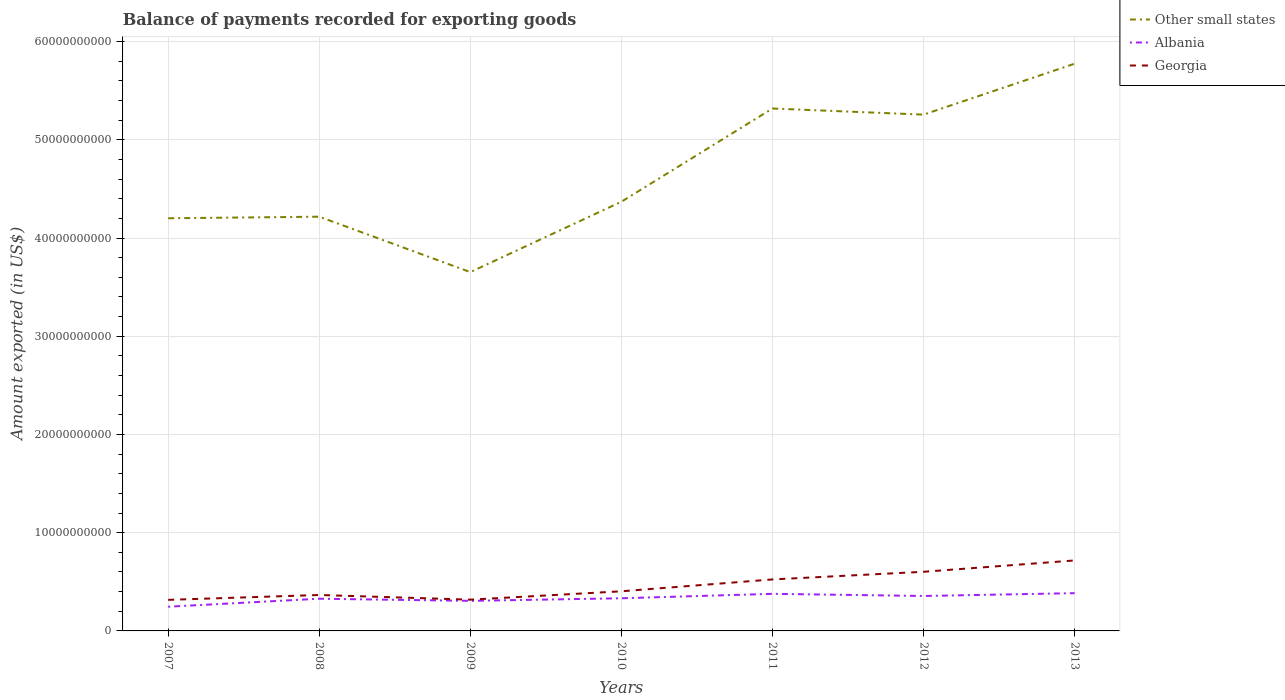Does the line corresponding to Georgia intersect with the line corresponding to Albania?
Your answer should be compact. No. Is the number of lines equal to the number of legend labels?
Make the answer very short. Yes. Across all years, what is the maximum amount exported in Georgia?
Ensure brevity in your answer.  3.16e+09. In which year was the amount exported in Georgia maximum?
Keep it short and to the point. 2007. What is the total amount exported in Georgia in the graph?
Give a very brief answer. -2.86e+09. What is the difference between the highest and the second highest amount exported in Albania?
Give a very brief answer. 1.38e+09. What is the difference between the highest and the lowest amount exported in Georgia?
Your response must be concise. 3. How many lines are there?
Offer a terse response. 3. How many years are there in the graph?
Ensure brevity in your answer.  7. Are the values on the major ticks of Y-axis written in scientific E-notation?
Your response must be concise. No. Does the graph contain grids?
Your response must be concise. Yes. Where does the legend appear in the graph?
Your answer should be very brief. Top right. What is the title of the graph?
Provide a succinct answer. Balance of payments recorded for exporting goods. Does "Armenia" appear as one of the legend labels in the graph?
Give a very brief answer. No. What is the label or title of the X-axis?
Provide a short and direct response. Years. What is the label or title of the Y-axis?
Your answer should be compact. Amount exported (in US$). What is the Amount exported (in US$) of Other small states in 2007?
Provide a succinct answer. 4.20e+1. What is the Amount exported (in US$) in Albania in 2007?
Ensure brevity in your answer.  2.46e+09. What is the Amount exported (in US$) in Georgia in 2007?
Your answer should be very brief. 3.16e+09. What is the Amount exported (in US$) in Other small states in 2008?
Provide a succinct answer. 4.22e+1. What is the Amount exported (in US$) in Albania in 2008?
Offer a very short reply. 3.28e+09. What is the Amount exported (in US$) in Georgia in 2008?
Your response must be concise. 3.66e+09. What is the Amount exported (in US$) of Other small states in 2009?
Offer a very short reply. 3.65e+1. What is the Amount exported (in US$) in Albania in 2009?
Give a very brief answer. 3.06e+09. What is the Amount exported (in US$) in Georgia in 2009?
Offer a very short reply. 3.18e+09. What is the Amount exported (in US$) in Other small states in 2010?
Provide a succinct answer. 4.37e+1. What is the Amount exported (in US$) in Albania in 2010?
Give a very brief answer. 3.32e+09. What is the Amount exported (in US$) in Georgia in 2010?
Ensure brevity in your answer.  4.03e+09. What is the Amount exported (in US$) of Other small states in 2011?
Your answer should be very brief. 5.32e+1. What is the Amount exported (in US$) of Albania in 2011?
Your answer should be compact. 3.78e+09. What is the Amount exported (in US$) of Georgia in 2011?
Your answer should be compact. 5.24e+09. What is the Amount exported (in US$) of Other small states in 2012?
Provide a succinct answer. 5.26e+1. What is the Amount exported (in US$) of Albania in 2012?
Offer a terse response. 3.56e+09. What is the Amount exported (in US$) of Georgia in 2012?
Your response must be concise. 6.02e+09. What is the Amount exported (in US$) in Other small states in 2013?
Make the answer very short. 5.77e+1. What is the Amount exported (in US$) of Albania in 2013?
Your answer should be compact. 3.84e+09. What is the Amount exported (in US$) of Georgia in 2013?
Make the answer very short. 7.17e+09. Across all years, what is the maximum Amount exported (in US$) in Other small states?
Ensure brevity in your answer.  5.77e+1. Across all years, what is the maximum Amount exported (in US$) in Albania?
Offer a terse response. 3.84e+09. Across all years, what is the maximum Amount exported (in US$) of Georgia?
Keep it short and to the point. 7.17e+09. Across all years, what is the minimum Amount exported (in US$) of Other small states?
Ensure brevity in your answer.  3.65e+1. Across all years, what is the minimum Amount exported (in US$) in Albania?
Provide a short and direct response. 2.46e+09. Across all years, what is the minimum Amount exported (in US$) in Georgia?
Keep it short and to the point. 3.16e+09. What is the total Amount exported (in US$) in Other small states in the graph?
Provide a succinct answer. 3.28e+11. What is the total Amount exported (in US$) in Albania in the graph?
Provide a succinct answer. 2.33e+1. What is the total Amount exported (in US$) in Georgia in the graph?
Ensure brevity in your answer.  3.25e+1. What is the difference between the Amount exported (in US$) of Other small states in 2007 and that in 2008?
Offer a terse response. -1.59e+08. What is the difference between the Amount exported (in US$) in Albania in 2007 and that in 2008?
Ensure brevity in your answer.  -8.14e+08. What is the difference between the Amount exported (in US$) of Georgia in 2007 and that in 2008?
Ensure brevity in your answer.  -4.96e+08. What is the difference between the Amount exported (in US$) in Other small states in 2007 and that in 2009?
Your response must be concise. 5.48e+09. What is the difference between the Amount exported (in US$) in Albania in 2007 and that in 2009?
Give a very brief answer. -5.97e+08. What is the difference between the Amount exported (in US$) in Georgia in 2007 and that in 2009?
Provide a succinct answer. -2.04e+07. What is the difference between the Amount exported (in US$) in Other small states in 2007 and that in 2010?
Keep it short and to the point. -1.68e+09. What is the difference between the Amount exported (in US$) of Albania in 2007 and that in 2010?
Offer a very short reply. -8.60e+08. What is the difference between the Amount exported (in US$) in Georgia in 2007 and that in 2010?
Your answer should be compact. -8.71e+08. What is the difference between the Amount exported (in US$) of Other small states in 2007 and that in 2011?
Your answer should be compact. -1.12e+1. What is the difference between the Amount exported (in US$) of Albania in 2007 and that in 2011?
Provide a short and direct response. -1.31e+09. What is the difference between the Amount exported (in US$) of Georgia in 2007 and that in 2011?
Give a very brief answer. -2.08e+09. What is the difference between the Amount exported (in US$) of Other small states in 2007 and that in 2012?
Provide a succinct answer. -1.06e+1. What is the difference between the Amount exported (in US$) of Albania in 2007 and that in 2012?
Your answer should be very brief. -1.09e+09. What is the difference between the Amount exported (in US$) of Georgia in 2007 and that in 2012?
Give a very brief answer. -2.86e+09. What is the difference between the Amount exported (in US$) in Other small states in 2007 and that in 2013?
Provide a short and direct response. -1.57e+1. What is the difference between the Amount exported (in US$) in Albania in 2007 and that in 2013?
Your answer should be compact. -1.38e+09. What is the difference between the Amount exported (in US$) in Georgia in 2007 and that in 2013?
Offer a very short reply. -4.01e+09. What is the difference between the Amount exported (in US$) in Other small states in 2008 and that in 2009?
Keep it short and to the point. 5.64e+09. What is the difference between the Amount exported (in US$) in Albania in 2008 and that in 2009?
Give a very brief answer. 2.17e+08. What is the difference between the Amount exported (in US$) in Georgia in 2008 and that in 2009?
Give a very brief answer. 4.75e+08. What is the difference between the Amount exported (in US$) in Other small states in 2008 and that in 2010?
Offer a terse response. -1.52e+09. What is the difference between the Amount exported (in US$) in Albania in 2008 and that in 2010?
Keep it short and to the point. -4.58e+07. What is the difference between the Amount exported (in US$) of Georgia in 2008 and that in 2010?
Your response must be concise. -3.76e+08. What is the difference between the Amount exported (in US$) in Other small states in 2008 and that in 2011?
Offer a very short reply. -1.10e+1. What is the difference between the Amount exported (in US$) in Albania in 2008 and that in 2011?
Give a very brief answer. -4.98e+08. What is the difference between the Amount exported (in US$) in Georgia in 2008 and that in 2011?
Your answer should be compact. -1.58e+09. What is the difference between the Amount exported (in US$) of Other small states in 2008 and that in 2012?
Your answer should be very brief. -1.04e+1. What is the difference between the Amount exported (in US$) of Albania in 2008 and that in 2012?
Make the answer very short. -2.79e+08. What is the difference between the Amount exported (in US$) of Georgia in 2008 and that in 2012?
Your response must be concise. -2.36e+09. What is the difference between the Amount exported (in US$) of Other small states in 2008 and that in 2013?
Your answer should be compact. -1.56e+1. What is the difference between the Amount exported (in US$) in Albania in 2008 and that in 2013?
Your answer should be very brief. -5.66e+08. What is the difference between the Amount exported (in US$) in Georgia in 2008 and that in 2013?
Your response must be concise. -3.52e+09. What is the difference between the Amount exported (in US$) of Other small states in 2009 and that in 2010?
Provide a succinct answer. -7.16e+09. What is the difference between the Amount exported (in US$) in Albania in 2009 and that in 2010?
Give a very brief answer. -2.63e+08. What is the difference between the Amount exported (in US$) in Georgia in 2009 and that in 2010?
Your response must be concise. -8.51e+08. What is the difference between the Amount exported (in US$) in Other small states in 2009 and that in 2011?
Your answer should be compact. -1.67e+1. What is the difference between the Amount exported (in US$) in Albania in 2009 and that in 2011?
Offer a terse response. -7.15e+08. What is the difference between the Amount exported (in US$) in Georgia in 2009 and that in 2011?
Ensure brevity in your answer.  -2.06e+09. What is the difference between the Amount exported (in US$) of Other small states in 2009 and that in 2012?
Your response must be concise. -1.60e+1. What is the difference between the Amount exported (in US$) of Albania in 2009 and that in 2012?
Provide a short and direct response. -4.96e+08. What is the difference between the Amount exported (in US$) of Georgia in 2009 and that in 2012?
Provide a short and direct response. -2.84e+09. What is the difference between the Amount exported (in US$) of Other small states in 2009 and that in 2013?
Give a very brief answer. -2.12e+1. What is the difference between the Amount exported (in US$) of Albania in 2009 and that in 2013?
Your answer should be very brief. -7.83e+08. What is the difference between the Amount exported (in US$) in Georgia in 2009 and that in 2013?
Make the answer very short. -3.99e+09. What is the difference between the Amount exported (in US$) in Other small states in 2010 and that in 2011?
Give a very brief answer. -9.49e+09. What is the difference between the Amount exported (in US$) in Albania in 2010 and that in 2011?
Your answer should be very brief. -4.52e+08. What is the difference between the Amount exported (in US$) of Georgia in 2010 and that in 2011?
Offer a very short reply. -1.21e+09. What is the difference between the Amount exported (in US$) of Other small states in 2010 and that in 2012?
Your answer should be very brief. -8.87e+09. What is the difference between the Amount exported (in US$) in Albania in 2010 and that in 2012?
Offer a very short reply. -2.33e+08. What is the difference between the Amount exported (in US$) of Georgia in 2010 and that in 2012?
Make the answer very short. -1.99e+09. What is the difference between the Amount exported (in US$) in Other small states in 2010 and that in 2013?
Offer a very short reply. -1.41e+1. What is the difference between the Amount exported (in US$) in Albania in 2010 and that in 2013?
Provide a short and direct response. -5.20e+08. What is the difference between the Amount exported (in US$) of Georgia in 2010 and that in 2013?
Keep it short and to the point. -3.14e+09. What is the difference between the Amount exported (in US$) of Other small states in 2011 and that in 2012?
Your response must be concise. 6.23e+08. What is the difference between the Amount exported (in US$) in Albania in 2011 and that in 2012?
Provide a short and direct response. 2.19e+08. What is the difference between the Amount exported (in US$) in Georgia in 2011 and that in 2012?
Offer a terse response. -7.79e+08. What is the difference between the Amount exported (in US$) of Other small states in 2011 and that in 2013?
Your answer should be very brief. -4.56e+09. What is the difference between the Amount exported (in US$) in Albania in 2011 and that in 2013?
Ensure brevity in your answer.  -6.77e+07. What is the difference between the Amount exported (in US$) in Georgia in 2011 and that in 2013?
Provide a short and direct response. -1.93e+09. What is the difference between the Amount exported (in US$) in Other small states in 2012 and that in 2013?
Give a very brief answer. -5.18e+09. What is the difference between the Amount exported (in US$) in Albania in 2012 and that in 2013?
Your answer should be very brief. -2.87e+08. What is the difference between the Amount exported (in US$) of Georgia in 2012 and that in 2013?
Offer a terse response. -1.15e+09. What is the difference between the Amount exported (in US$) of Other small states in 2007 and the Amount exported (in US$) of Albania in 2008?
Offer a very short reply. 3.87e+1. What is the difference between the Amount exported (in US$) of Other small states in 2007 and the Amount exported (in US$) of Georgia in 2008?
Give a very brief answer. 3.84e+1. What is the difference between the Amount exported (in US$) of Albania in 2007 and the Amount exported (in US$) of Georgia in 2008?
Your response must be concise. -1.19e+09. What is the difference between the Amount exported (in US$) in Other small states in 2007 and the Amount exported (in US$) in Albania in 2009?
Ensure brevity in your answer.  3.90e+1. What is the difference between the Amount exported (in US$) in Other small states in 2007 and the Amount exported (in US$) in Georgia in 2009?
Provide a short and direct response. 3.88e+1. What is the difference between the Amount exported (in US$) of Albania in 2007 and the Amount exported (in US$) of Georgia in 2009?
Provide a short and direct response. -7.19e+08. What is the difference between the Amount exported (in US$) in Other small states in 2007 and the Amount exported (in US$) in Albania in 2010?
Give a very brief answer. 3.87e+1. What is the difference between the Amount exported (in US$) of Other small states in 2007 and the Amount exported (in US$) of Georgia in 2010?
Keep it short and to the point. 3.80e+1. What is the difference between the Amount exported (in US$) of Albania in 2007 and the Amount exported (in US$) of Georgia in 2010?
Give a very brief answer. -1.57e+09. What is the difference between the Amount exported (in US$) in Other small states in 2007 and the Amount exported (in US$) in Albania in 2011?
Your answer should be compact. 3.82e+1. What is the difference between the Amount exported (in US$) in Other small states in 2007 and the Amount exported (in US$) in Georgia in 2011?
Give a very brief answer. 3.68e+1. What is the difference between the Amount exported (in US$) of Albania in 2007 and the Amount exported (in US$) of Georgia in 2011?
Your answer should be very brief. -2.78e+09. What is the difference between the Amount exported (in US$) of Other small states in 2007 and the Amount exported (in US$) of Albania in 2012?
Your answer should be compact. 3.85e+1. What is the difference between the Amount exported (in US$) in Other small states in 2007 and the Amount exported (in US$) in Georgia in 2012?
Ensure brevity in your answer.  3.60e+1. What is the difference between the Amount exported (in US$) in Albania in 2007 and the Amount exported (in US$) in Georgia in 2012?
Your answer should be very brief. -3.56e+09. What is the difference between the Amount exported (in US$) of Other small states in 2007 and the Amount exported (in US$) of Albania in 2013?
Make the answer very short. 3.82e+1. What is the difference between the Amount exported (in US$) in Other small states in 2007 and the Amount exported (in US$) in Georgia in 2013?
Offer a terse response. 3.48e+1. What is the difference between the Amount exported (in US$) of Albania in 2007 and the Amount exported (in US$) of Georgia in 2013?
Your answer should be compact. -4.71e+09. What is the difference between the Amount exported (in US$) of Other small states in 2008 and the Amount exported (in US$) of Albania in 2009?
Provide a succinct answer. 3.91e+1. What is the difference between the Amount exported (in US$) of Other small states in 2008 and the Amount exported (in US$) of Georgia in 2009?
Offer a very short reply. 3.90e+1. What is the difference between the Amount exported (in US$) in Albania in 2008 and the Amount exported (in US$) in Georgia in 2009?
Offer a very short reply. 9.52e+07. What is the difference between the Amount exported (in US$) in Other small states in 2008 and the Amount exported (in US$) in Albania in 2010?
Make the answer very short. 3.88e+1. What is the difference between the Amount exported (in US$) in Other small states in 2008 and the Amount exported (in US$) in Georgia in 2010?
Keep it short and to the point. 3.81e+1. What is the difference between the Amount exported (in US$) in Albania in 2008 and the Amount exported (in US$) in Georgia in 2010?
Your response must be concise. -7.56e+08. What is the difference between the Amount exported (in US$) of Other small states in 2008 and the Amount exported (in US$) of Albania in 2011?
Make the answer very short. 3.84e+1. What is the difference between the Amount exported (in US$) in Other small states in 2008 and the Amount exported (in US$) in Georgia in 2011?
Make the answer very short. 3.69e+1. What is the difference between the Amount exported (in US$) of Albania in 2008 and the Amount exported (in US$) of Georgia in 2011?
Make the answer very short. -1.96e+09. What is the difference between the Amount exported (in US$) in Other small states in 2008 and the Amount exported (in US$) in Albania in 2012?
Your answer should be compact. 3.86e+1. What is the difference between the Amount exported (in US$) of Other small states in 2008 and the Amount exported (in US$) of Georgia in 2012?
Keep it short and to the point. 3.61e+1. What is the difference between the Amount exported (in US$) of Albania in 2008 and the Amount exported (in US$) of Georgia in 2012?
Offer a very short reply. -2.74e+09. What is the difference between the Amount exported (in US$) in Other small states in 2008 and the Amount exported (in US$) in Albania in 2013?
Offer a very short reply. 3.83e+1. What is the difference between the Amount exported (in US$) in Other small states in 2008 and the Amount exported (in US$) in Georgia in 2013?
Keep it short and to the point. 3.50e+1. What is the difference between the Amount exported (in US$) of Albania in 2008 and the Amount exported (in US$) of Georgia in 2013?
Give a very brief answer. -3.90e+09. What is the difference between the Amount exported (in US$) in Other small states in 2009 and the Amount exported (in US$) in Albania in 2010?
Your answer should be very brief. 3.32e+1. What is the difference between the Amount exported (in US$) in Other small states in 2009 and the Amount exported (in US$) in Georgia in 2010?
Make the answer very short. 3.25e+1. What is the difference between the Amount exported (in US$) of Albania in 2009 and the Amount exported (in US$) of Georgia in 2010?
Keep it short and to the point. -9.73e+08. What is the difference between the Amount exported (in US$) in Other small states in 2009 and the Amount exported (in US$) in Albania in 2011?
Give a very brief answer. 3.28e+1. What is the difference between the Amount exported (in US$) of Other small states in 2009 and the Amount exported (in US$) of Georgia in 2011?
Offer a very short reply. 3.13e+1. What is the difference between the Amount exported (in US$) in Albania in 2009 and the Amount exported (in US$) in Georgia in 2011?
Your answer should be compact. -2.18e+09. What is the difference between the Amount exported (in US$) of Other small states in 2009 and the Amount exported (in US$) of Albania in 2012?
Give a very brief answer. 3.30e+1. What is the difference between the Amount exported (in US$) of Other small states in 2009 and the Amount exported (in US$) of Georgia in 2012?
Your answer should be compact. 3.05e+1. What is the difference between the Amount exported (in US$) in Albania in 2009 and the Amount exported (in US$) in Georgia in 2012?
Provide a succinct answer. -2.96e+09. What is the difference between the Amount exported (in US$) in Other small states in 2009 and the Amount exported (in US$) in Albania in 2013?
Offer a very short reply. 3.27e+1. What is the difference between the Amount exported (in US$) of Other small states in 2009 and the Amount exported (in US$) of Georgia in 2013?
Your answer should be very brief. 2.94e+1. What is the difference between the Amount exported (in US$) of Albania in 2009 and the Amount exported (in US$) of Georgia in 2013?
Provide a short and direct response. -4.11e+09. What is the difference between the Amount exported (in US$) in Other small states in 2010 and the Amount exported (in US$) in Albania in 2011?
Your answer should be compact. 3.99e+1. What is the difference between the Amount exported (in US$) in Other small states in 2010 and the Amount exported (in US$) in Georgia in 2011?
Offer a very short reply. 3.85e+1. What is the difference between the Amount exported (in US$) in Albania in 2010 and the Amount exported (in US$) in Georgia in 2011?
Offer a very short reply. -1.92e+09. What is the difference between the Amount exported (in US$) in Other small states in 2010 and the Amount exported (in US$) in Albania in 2012?
Make the answer very short. 4.01e+1. What is the difference between the Amount exported (in US$) of Other small states in 2010 and the Amount exported (in US$) of Georgia in 2012?
Ensure brevity in your answer.  3.77e+1. What is the difference between the Amount exported (in US$) in Albania in 2010 and the Amount exported (in US$) in Georgia in 2012?
Your answer should be compact. -2.70e+09. What is the difference between the Amount exported (in US$) of Other small states in 2010 and the Amount exported (in US$) of Albania in 2013?
Your response must be concise. 3.98e+1. What is the difference between the Amount exported (in US$) of Other small states in 2010 and the Amount exported (in US$) of Georgia in 2013?
Your answer should be compact. 3.65e+1. What is the difference between the Amount exported (in US$) in Albania in 2010 and the Amount exported (in US$) in Georgia in 2013?
Make the answer very short. -3.85e+09. What is the difference between the Amount exported (in US$) in Other small states in 2011 and the Amount exported (in US$) in Albania in 2012?
Make the answer very short. 4.96e+1. What is the difference between the Amount exported (in US$) of Other small states in 2011 and the Amount exported (in US$) of Georgia in 2012?
Provide a succinct answer. 4.72e+1. What is the difference between the Amount exported (in US$) of Albania in 2011 and the Amount exported (in US$) of Georgia in 2012?
Make the answer very short. -2.24e+09. What is the difference between the Amount exported (in US$) of Other small states in 2011 and the Amount exported (in US$) of Albania in 2013?
Make the answer very short. 4.93e+1. What is the difference between the Amount exported (in US$) in Other small states in 2011 and the Amount exported (in US$) in Georgia in 2013?
Give a very brief answer. 4.60e+1. What is the difference between the Amount exported (in US$) in Albania in 2011 and the Amount exported (in US$) in Georgia in 2013?
Your answer should be very brief. -3.40e+09. What is the difference between the Amount exported (in US$) in Other small states in 2012 and the Amount exported (in US$) in Albania in 2013?
Make the answer very short. 4.87e+1. What is the difference between the Amount exported (in US$) of Other small states in 2012 and the Amount exported (in US$) of Georgia in 2013?
Give a very brief answer. 4.54e+1. What is the difference between the Amount exported (in US$) of Albania in 2012 and the Amount exported (in US$) of Georgia in 2013?
Give a very brief answer. -3.62e+09. What is the average Amount exported (in US$) in Other small states per year?
Ensure brevity in your answer.  4.68e+1. What is the average Amount exported (in US$) in Albania per year?
Your answer should be very brief. 3.33e+09. What is the average Amount exported (in US$) in Georgia per year?
Make the answer very short. 4.64e+09. In the year 2007, what is the difference between the Amount exported (in US$) in Other small states and Amount exported (in US$) in Albania?
Provide a succinct answer. 3.95e+1. In the year 2007, what is the difference between the Amount exported (in US$) in Other small states and Amount exported (in US$) in Georgia?
Keep it short and to the point. 3.88e+1. In the year 2007, what is the difference between the Amount exported (in US$) of Albania and Amount exported (in US$) of Georgia?
Your answer should be compact. -6.98e+08. In the year 2008, what is the difference between the Amount exported (in US$) of Other small states and Amount exported (in US$) of Albania?
Your answer should be compact. 3.89e+1. In the year 2008, what is the difference between the Amount exported (in US$) of Other small states and Amount exported (in US$) of Georgia?
Make the answer very short. 3.85e+1. In the year 2008, what is the difference between the Amount exported (in US$) in Albania and Amount exported (in US$) in Georgia?
Offer a terse response. -3.80e+08. In the year 2009, what is the difference between the Amount exported (in US$) of Other small states and Amount exported (in US$) of Albania?
Keep it short and to the point. 3.35e+1. In the year 2009, what is the difference between the Amount exported (in US$) of Other small states and Amount exported (in US$) of Georgia?
Your answer should be very brief. 3.33e+1. In the year 2009, what is the difference between the Amount exported (in US$) of Albania and Amount exported (in US$) of Georgia?
Offer a very short reply. -1.22e+08. In the year 2010, what is the difference between the Amount exported (in US$) in Other small states and Amount exported (in US$) in Albania?
Offer a very short reply. 4.04e+1. In the year 2010, what is the difference between the Amount exported (in US$) in Other small states and Amount exported (in US$) in Georgia?
Your answer should be very brief. 3.97e+1. In the year 2010, what is the difference between the Amount exported (in US$) in Albania and Amount exported (in US$) in Georgia?
Your answer should be very brief. -7.10e+08. In the year 2011, what is the difference between the Amount exported (in US$) of Other small states and Amount exported (in US$) of Albania?
Your answer should be very brief. 4.94e+1. In the year 2011, what is the difference between the Amount exported (in US$) of Other small states and Amount exported (in US$) of Georgia?
Provide a short and direct response. 4.79e+1. In the year 2011, what is the difference between the Amount exported (in US$) in Albania and Amount exported (in US$) in Georgia?
Your answer should be very brief. -1.47e+09. In the year 2012, what is the difference between the Amount exported (in US$) in Other small states and Amount exported (in US$) in Albania?
Provide a short and direct response. 4.90e+1. In the year 2012, what is the difference between the Amount exported (in US$) in Other small states and Amount exported (in US$) in Georgia?
Your response must be concise. 4.65e+1. In the year 2012, what is the difference between the Amount exported (in US$) in Albania and Amount exported (in US$) in Georgia?
Your answer should be compact. -2.46e+09. In the year 2013, what is the difference between the Amount exported (in US$) of Other small states and Amount exported (in US$) of Albania?
Provide a succinct answer. 5.39e+1. In the year 2013, what is the difference between the Amount exported (in US$) of Other small states and Amount exported (in US$) of Georgia?
Your answer should be compact. 5.06e+1. In the year 2013, what is the difference between the Amount exported (in US$) in Albania and Amount exported (in US$) in Georgia?
Keep it short and to the point. -3.33e+09. What is the ratio of the Amount exported (in US$) of Other small states in 2007 to that in 2008?
Make the answer very short. 1. What is the ratio of the Amount exported (in US$) in Albania in 2007 to that in 2008?
Ensure brevity in your answer.  0.75. What is the ratio of the Amount exported (in US$) in Georgia in 2007 to that in 2008?
Provide a short and direct response. 0.86. What is the ratio of the Amount exported (in US$) in Other small states in 2007 to that in 2009?
Your response must be concise. 1.15. What is the ratio of the Amount exported (in US$) of Albania in 2007 to that in 2009?
Make the answer very short. 0.81. What is the ratio of the Amount exported (in US$) of Other small states in 2007 to that in 2010?
Give a very brief answer. 0.96. What is the ratio of the Amount exported (in US$) of Albania in 2007 to that in 2010?
Offer a terse response. 0.74. What is the ratio of the Amount exported (in US$) of Georgia in 2007 to that in 2010?
Give a very brief answer. 0.78. What is the ratio of the Amount exported (in US$) of Other small states in 2007 to that in 2011?
Give a very brief answer. 0.79. What is the ratio of the Amount exported (in US$) in Albania in 2007 to that in 2011?
Your answer should be very brief. 0.65. What is the ratio of the Amount exported (in US$) of Georgia in 2007 to that in 2011?
Your answer should be compact. 0.6. What is the ratio of the Amount exported (in US$) of Other small states in 2007 to that in 2012?
Your answer should be compact. 0.8. What is the ratio of the Amount exported (in US$) of Albania in 2007 to that in 2012?
Give a very brief answer. 0.69. What is the ratio of the Amount exported (in US$) in Georgia in 2007 to that in 2012?
Your answer should be very brief. 0.53. What is the ratio of the Amount exported (in US$) of Other small states in 2007 to that in 2013?
Keep it short and to the point. 0.73. What is the ratio of the Amount exported (in US$) in Albania in 2007 to that in 2013?
Your answer should be compact. 0.64. What is the ratio of the Amount exported (in US$) of Georgia in 2007 to that in 2013?
Offer a terse response. 0.44. What is the ratio of the Amount exported (in US$) of Other small states in 2008 to that in 2009?
Your response must be concise. 1.15. What is the ratio of the Amount exported (in US$) of Albania in 2008 to that in 2009?
Offer a terse response. 1.07. What is the ratio of the Amount exported (in US$) in Georgia in 2008 to that in 2009?
Your response must be concise. 1.15. What is the ratio of the Amount exported (in US$) in Other small states in 2008 to that in 2010?
Give a very brief answer. 0.97. What is the ratio of the Amount exported (in US$) in Albania in 2008 to that in 2010?
Make the answer very short. 0.99. What is the ratio of the Amount exported (in US$) of Georgia in 2008 to that in 2010?
Provide a succinct answer. 0.91. What is the ratio of the Amount exported (in US$) in Other small states in 2008 to that in 2011?
Give a very brief answer. 0.79. What is the ratio of the Amount exported (in US$) in Albania in 2008 to that in 2011?
Your answer should be very brief. 0.87. What is the ratio of the Amount exported (in US$) of Georgia in 2008 to that in 2011?
Offer a very short reply. 0.7. What is the ratio of the Amount exported (in US$) of Other small states in 2008 to that in 2012?
Your answer should be very brief. 0.8. What is the ratio of the Amount exported (in US$) in Albania in 2008 to that in 2012?
Offer a very short reply. 0.92. What is the ratio of the Amount exported (in US$) in Georgia in 2008 to that in 2012?
Provide a succinct answer. 0.61. What is the ratio of the Amount exported (in US$) in Other small states in 2008 to that in 2013?
Provide a succinct answer. 0.73. What is the ratio of the Amount exported (in US$) of Albania in 2008 to that in 2013?
Offer a very short reply. 0.85. What is the ratio of the Amount exported (in US$) of Georgia in 2008 to that in 2013?
Your answer should be compact. 0.51. What is the ratio of the Amount exported (in US$) in Other small states in 2009 to that in 2010?
Offer a very short reply. 0.84. What is the ratio of the Amount exported (in US$) of Albania in 2009 to that in 2010?
Your answer should be compact. 0.92. What is the ratio of the Amount exported (in US$) of Georgia in 2009 to that in 2010?
Keep it short and to the point. 0.79. What is the ratio of the Amount exported (in US$) in Other small states in 2009 to that in 2011?
Make the answer very short. 0.69. What is the ratio of the Amount exported (in US$) of Albania in 2009 to that in 2011?
Your answer should be very brief. 0.81. What is the ratio of the Amount exported (in US$) of Georgia in 2009 to that in 2011?
Keep it short and to the point. 0.61. What is the ratio of the Amount exported (in US$) in Other small states in 2009 to that in 2012?
Your response must be concise. 0.69. What is the ratio of the Amount exported (in US$) in Albania in 2009 to that in 2012?
Keep it short and to the point. 0.86. What is the ratio of the Amount exported (in US$) of Georgia in 2009 to that in 2012?
Offer a terse response. 0.53. What is the ratio of the Amount exported (in US$) in Other small states in 2009 to that in 2013?
Offer a terse response. 0.63. What is the ratio of the Amount exported (in US$) of Albania in 2009 to that in 2013?
Your answer should be compact. 0.8. What is the ratio of the Amount exported (in US$) in Georgia in 2009 to that in 2013?
Your answer should be very brief. 0.44. What is the ratio of the Amount exported (in US$) in Other small states in 2010 to that in 2011?
Ensure brevity in your answer.  0.82. What is the ratio of the Amount exported (in US$) of Albania in 2010 to that in 2011?
Your response must be concise. 0.88. What is the ratio of the Amount exported (in US$) of Georgia in 2010 to that in 2011?
Offer a terse response. 0.77. What is the ratio of the Amount exported (in US$) of Other small states in 2010 to that in 2012?
Provide a short and direct response. 0.83. What is the ratio of the Amount exported (in US$) of Albania in 2010 to that in 2012?
Offer a very short reply. 0.93. What is the ratio of the Amount exported (in US$) of Georgia in 2010 to that in 2012?
Keep it short and to the point. 0.67. What is the ratio of the Amount exported (in US$) in Other small states in 2010 to that in 2013?
Your response must be concise. 0.76. What is the ratio of the Amount exported (in US$) in Albania in 2010 to that in 2013?
Your answer should be very brief. 0.86. What is the ratio of the Amount exported (in US$) of Georgia in 2010 to that in 2013?
Your answer should be compact. 0.56. What is the ratio of the Amount exported (in US$) in Other small states in 2011 to that in 2012?
Ensure brevity in your answer.  1.01. What is the ratio of the Amount exported (in US$) in Albania in 2011 to that in 2012?
Keep it short and to the point. 1.06. What is the ratio of the Amount exported (in US$) in Georgia in 2011 to that in 2012?
Your answer should be compact. 0.87. What is the ratio of the Amount exported (in US$) in Other small states in 2011 to that in 2013?
Your response must be concise. 0.92. What is the ratio of the Amount exported (in US$) in Albania in 2011 to that in 2013?
Keep it short and to the point. 0.98. What is the ratio of the Amount exported (in US$) in Georgia in 2011 to that in 2013?
Give a very brief answer. 0.73. What is the ratio of the Amount exported (in US$) in Other small states in 2012 to that in 2013?
Offer a terse response. 0.91. What is the ratio of the Amount exported (in US$) of Albania in 2012 to that in 2013?
Ensure brevity in your answer.  0.93. What is the ratio of the Amount exported (in US$) of Georgia in 2012 to that in 2013?
Ensure brevity in your answer.  0.84. What is the difference between the highest and the second highest Amount exported (in US$) of Other small states?
Keep it short and to the point. 4.56e+09. What is the difference between the highest and the second highest Amount exported (in US$) of Albania?
Make the answer very short. 6.77e+07. What is the difference between the highest and the second highest Amount exported (in US$) in Georgia?
Provide a succinct answer. 1.15e+09. What is the difference between the highest and the lowest Amount exported (in US$) in Other small states?
Your answer should be compact. 2.12e+1. What is the difference between the highest and the lowest Amount exported (in US$) of Albania?
Make the answer very short. 1.38e+09. What is the difference between the highest and the lowest Amount exported (in US$) of Georgia?
Your answer should be very brief. 4.01e+09. 